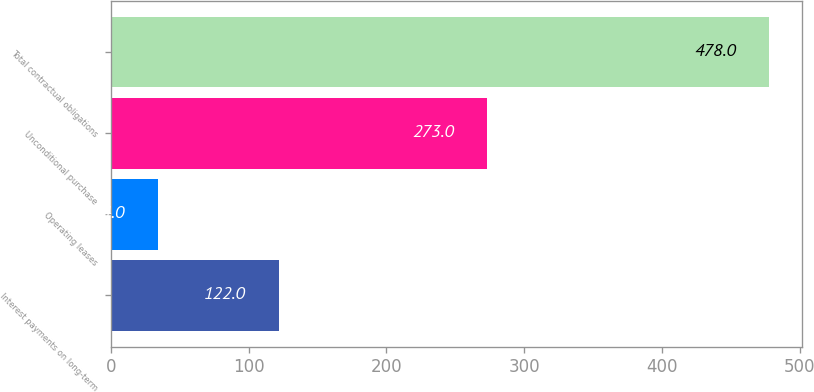Convert chart. <chart><loc_0><loc_0><loc_500><loc_500><bar_chart><fcel>Interest payments on long-term<fcel>Operating leases<fcel>Unconditional purchase<fcel>Total contractual obligations<nl><fcel>122<fcel>34<fcel>273<fcel>478<nl></chart> 